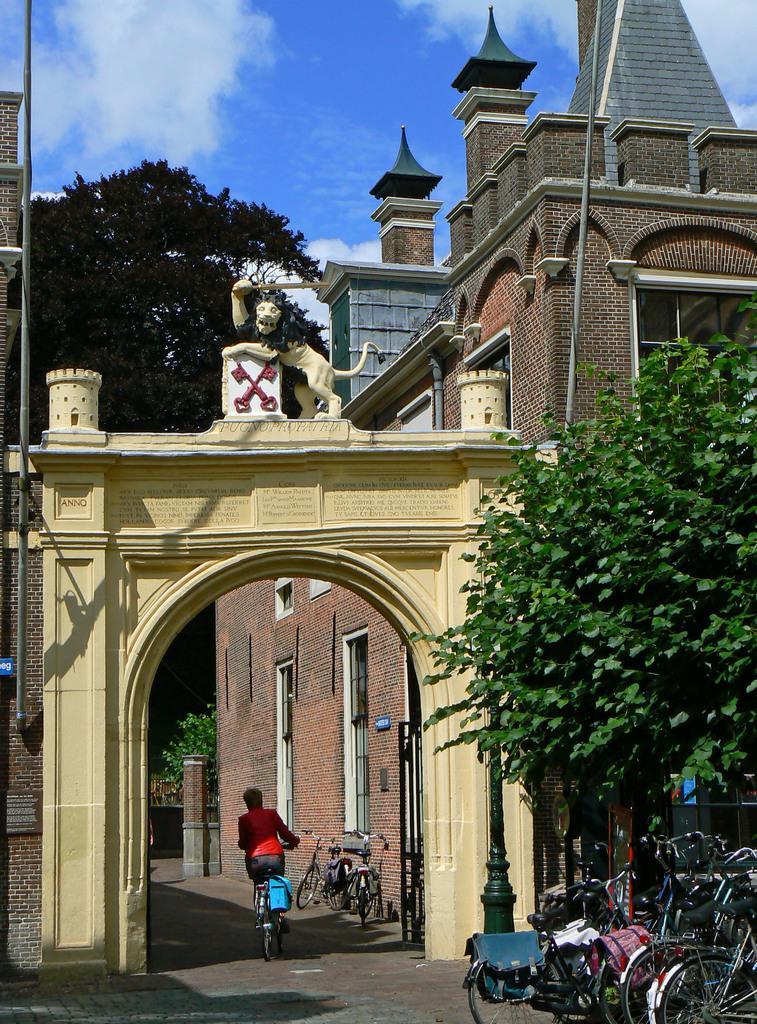Can you describe this image briefly? On the right side there is a tree, building with windows, brick walls. Also there are cycles. And there is a pole. And there is an arch. On the arch there is a statue of a lion. In the back there is a tree and sky with clouds. There is a road. A person is riding a cycle. Near to the building there are cycles. 